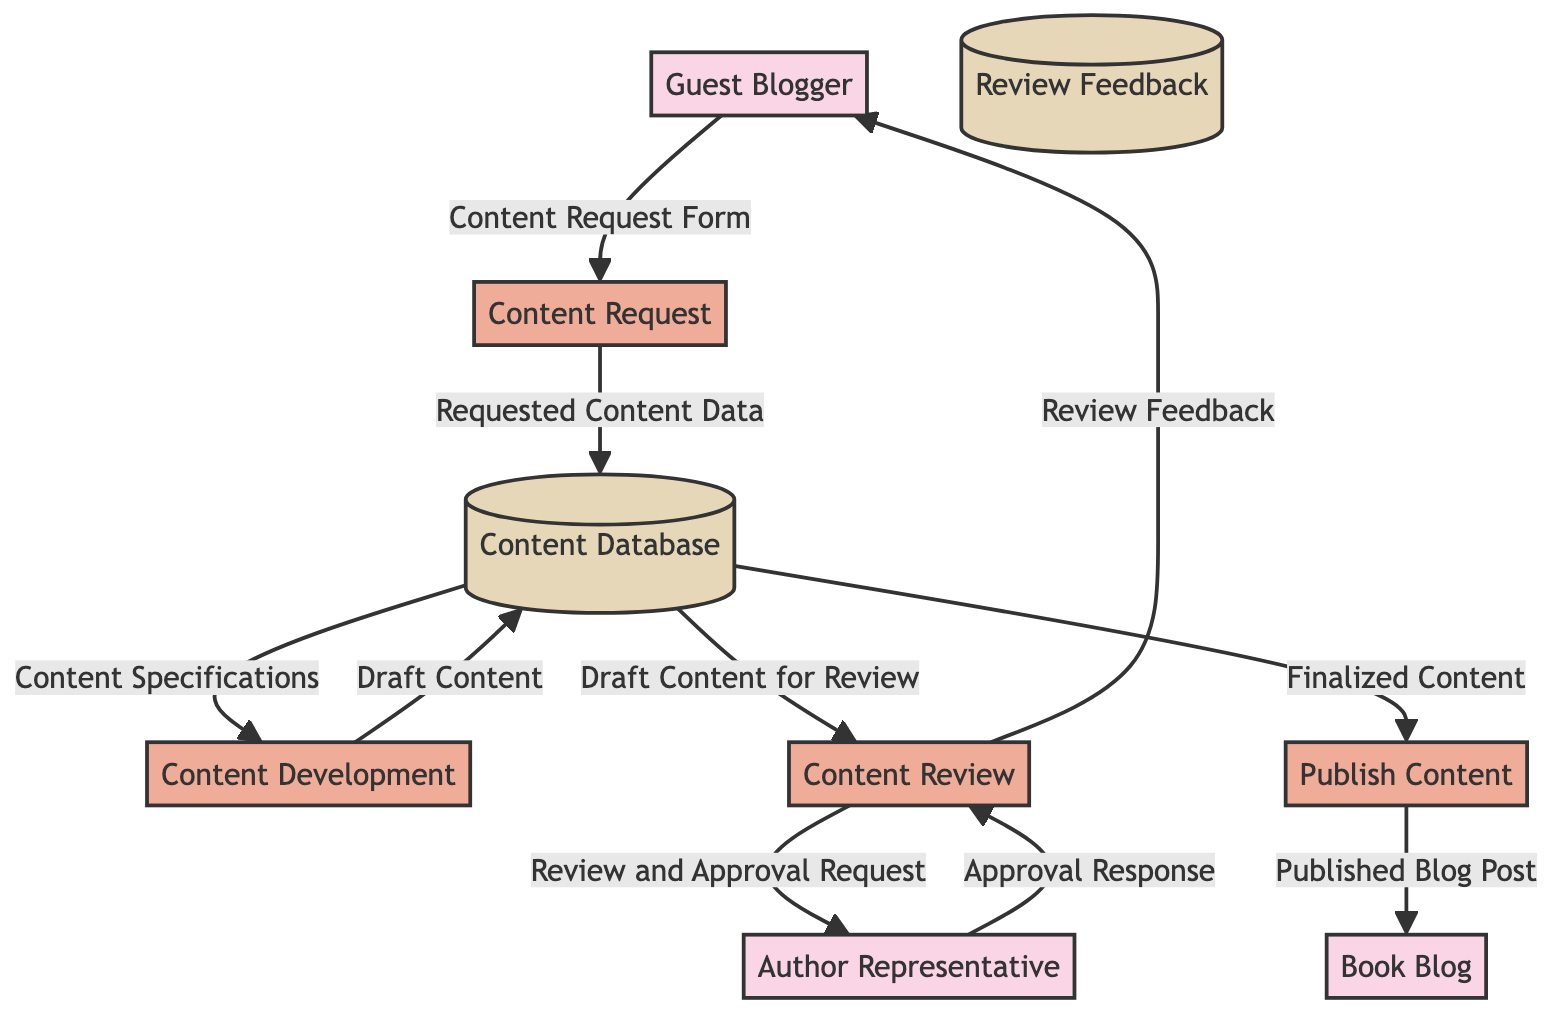What is the first process in the diagram? The diagram begins with the "Content Request" process, which is labeled as process ID 1, indicating it is the first step in the workflow.
Answer: Content Request How many external entities are in the diagram? The diagram features two external entities: "Guest Blogger" and "Author Representative." Counting them gives a total of two entities.
Answer: 2 What data store receives feedback from the content review process? The "Review Feedback" data store is where feedback and review notes collected from the Content Review process are stored, as indicated by the flow from Content Review to this datastore.
Answer: Review Feedback What type of data does the Content Development process output to the Content Database? The Content Development process outputs "Draft Content" to the Content Database, as shown by the arrow directed from the Content Development process to the Content Database.
Answer: Draft Content Which external entity provides the content request form? The "Guest Blogger" is the external entity that provides the "Content Request Form," as shown by the flow from Guest Blogger to the Content Request process.
Answer: Guest Blogger What is the final outcome of the Publish Content process? The final outcome of the Publish Content process is the "Published Blog Post," which is directed to the Book Blog, indicating that this is the last step in the workflow.
Answer: Published Blog Post Which process requests approval from the Author Representative? The "Content Review" process requests approval from the Author Representative, as indicated by the flow labeled "Review and Approval Request" that leads to the Author Representative.
Answer: Content Review How many processes are illustrated in the diagram? The diagram illustrates four processes: Content Request, Content Development, Content Review, and Publish Content. Counting them leads to a total of four processes.
Answer: 4 What do the arrows represent in the diagram? The arrows in the diagram represent the flow of data between the various entities, processes, and data stores, indicating where the information is sent or received through the workflow.
Answer: Data flow 